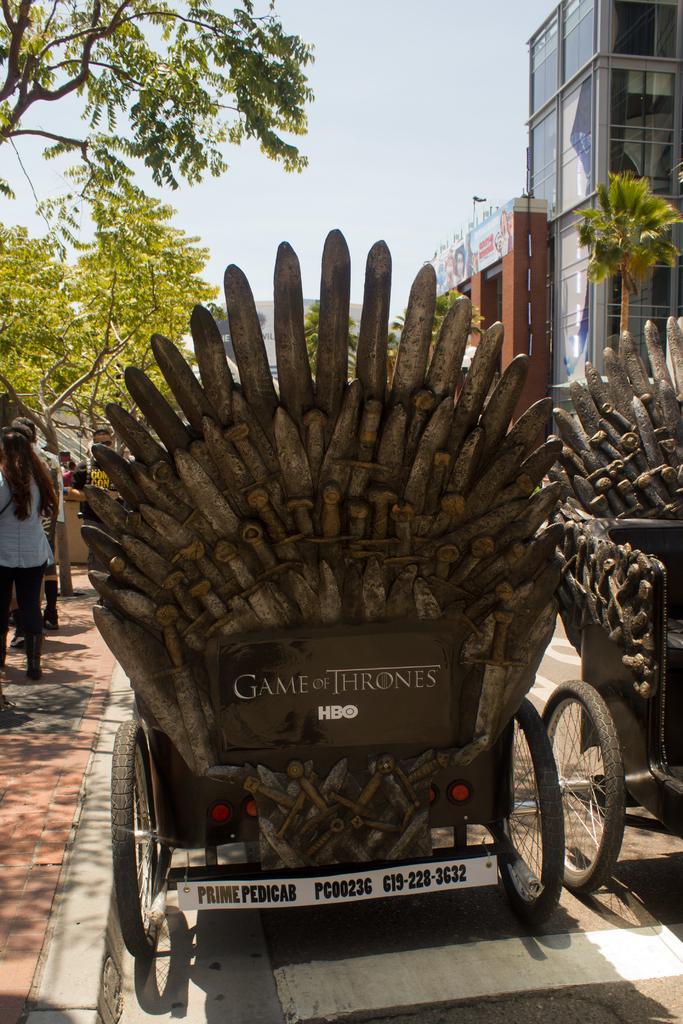Describe this image in one or two sentences. In this picture we can observe vehicles on the road. In the left there is a footpath on which some people were standing. In the right side there is a building. We can observe some trees. In the background there is a sky. 